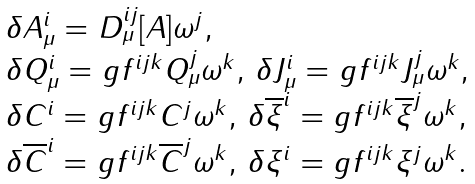<formula> <loc_0><loc_0><loc_500><loc_500>\begin{array} { l } \delta A _ { \mu } ^ { i } = D _ { \mu } ^ { i j } [ A ] \omega ^ { j } , \\ \delta Q _ { \mu } ^ { i } = g f ^ { i j k } Q _ { \mu } ^ { j } \omega ^ { k } , \, \delta J _ { \mu } ^ { i } = g f ^ { i j k } J _ { \mu } ^ { j } \omega ^ { k } , \\ \delta C ^ { i } = g f ^ { i j k } C ^ { j } \omega ^ { k } , \, \delta \overline { \xi } ^ { i } = g f ^ { i j k } \overline { \xi } ^ { j } \omega ^ { k } , \\ \delta \overline { C } ^ { i } = g f ^ { i j k } \overline { C } ^ { j } \omega ^ { k } , \, \delta \xi ^ { i } = g f ^ { i j k } \xi ^ { j } \omega ^ { k } . \\ \end{array}</formula> 